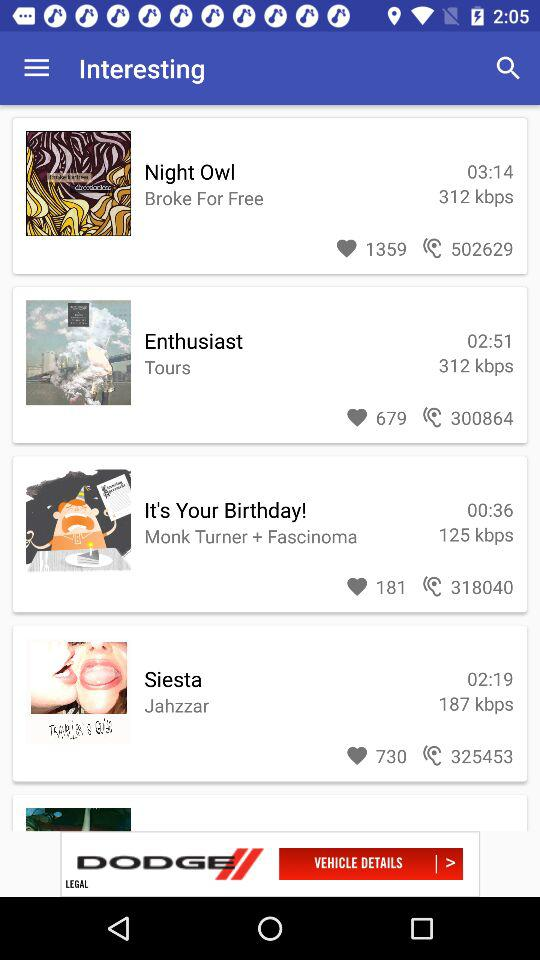How many people are listening to the "Enthusiast"? The number of people who are listening to the "Enthusiast" is 300864. 